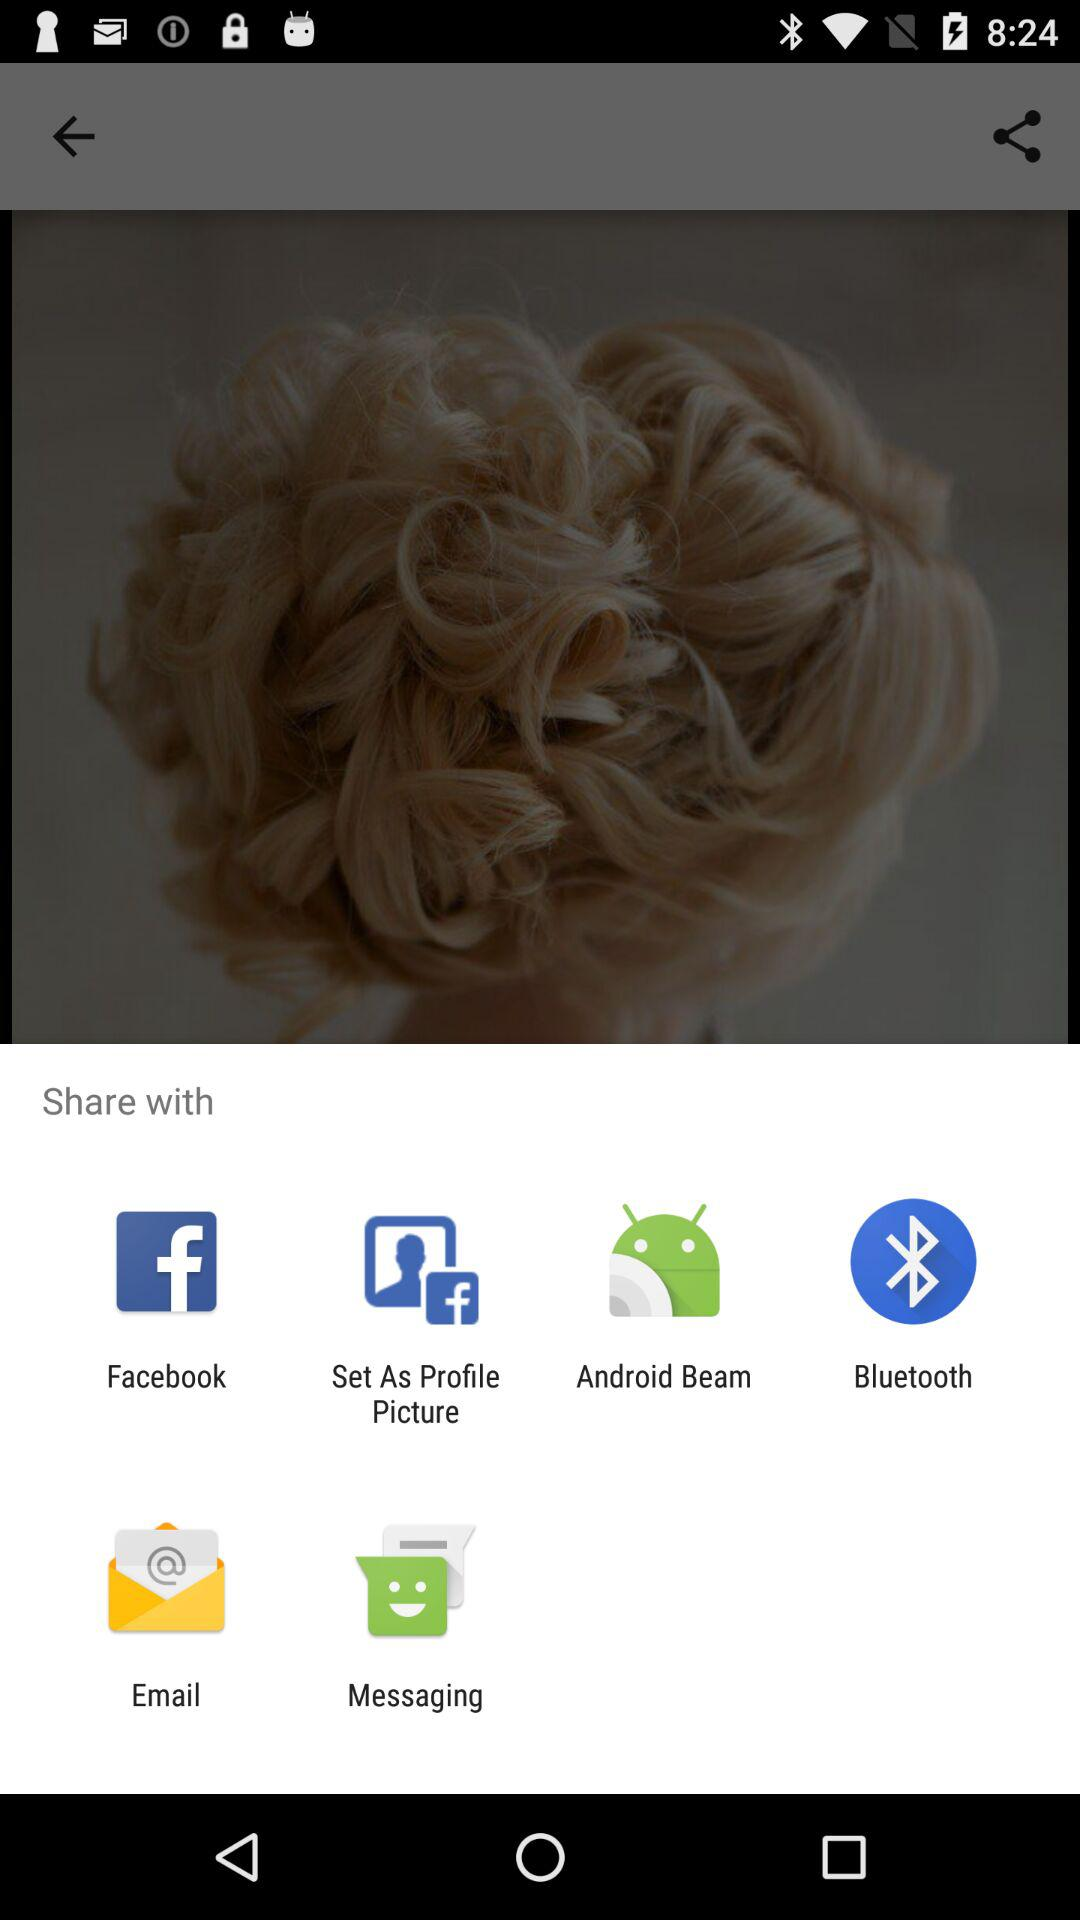Through which application can we share the image? You can share the image through "Facebook", "Set As Profile Picture", "Android Beam", "Bluetooth", "Email" and "Messaging". 